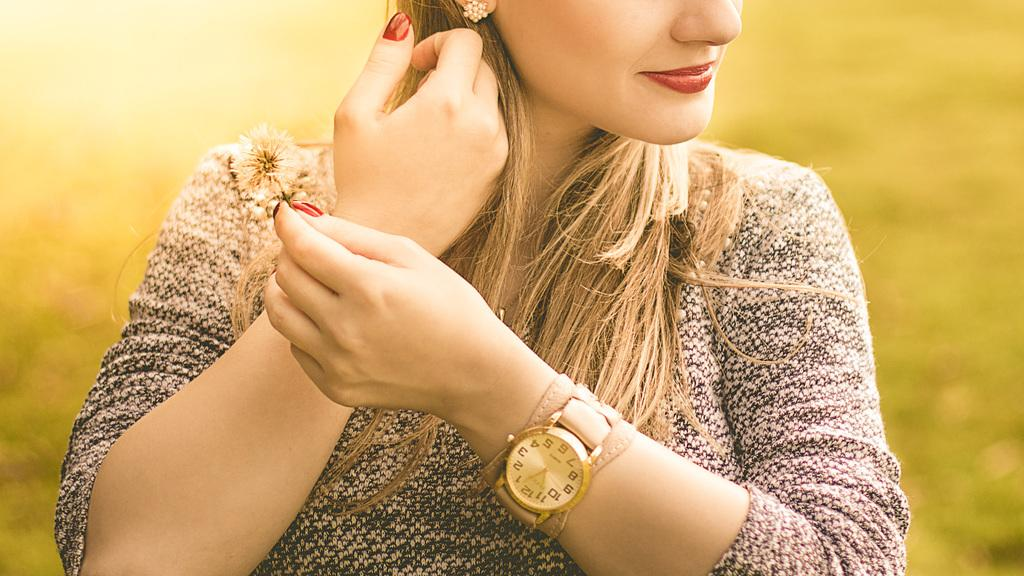Who is present in the image? There is a woman in the image. What is the woman wearing on her hand? The woman is wearing a watch on her hand. What can be seen on the woman's fingers? The woman has nail polish on her fingers. What type of crime is being committed in the image? There is no crime being committed in the image; it features a woman wearing a watch and having nail polish on her fingers. How many tickets are visible in the image? There are no tickets present in the image. 